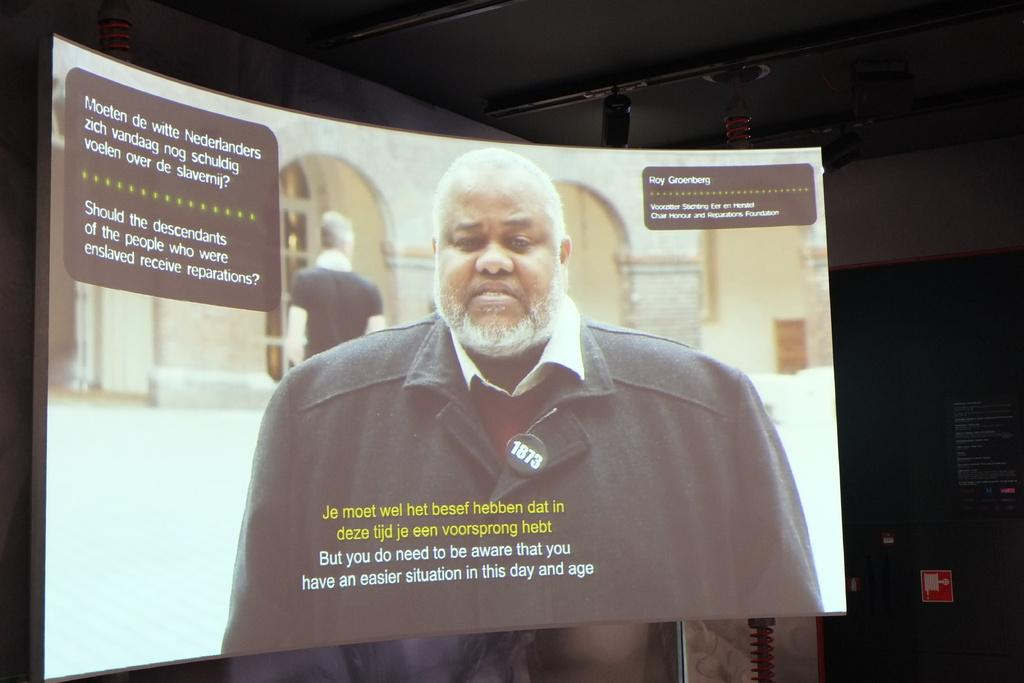What is displayed on the screen in the image? There is a screen with text in the image. Can you describe the people visible in the image? There are persons visible in the image. What is written on the board in the background? There is a board with text in the background of the image. What can be seen at the top of the image? There are objects at the top of the image. How many cows are grazing in the territory shown in the image? There are no cows or territory present in the image; it features a screen with text, persons, a board with text, and objects at the top. 